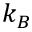<formula> <loc_0><loc_0><loc_500><loc_500>k _ { B }</formula> 